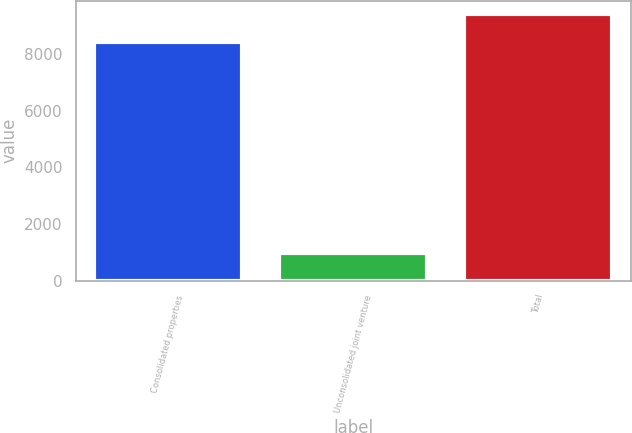<chart> <loc_0><loc_0><loc_500><loc_500><bar_chart><fcel>Consolidated properties<fcel>Unconsolidated joint venture<fcel>Total<nl><fcel>8418<fcel>992<fcel>9410<nl></chart> 